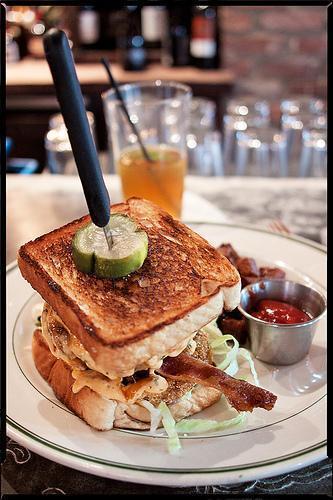How many pickles?
Give a very brief answer. 1. How many sandwiches?
Give a very brief answer. 1. 